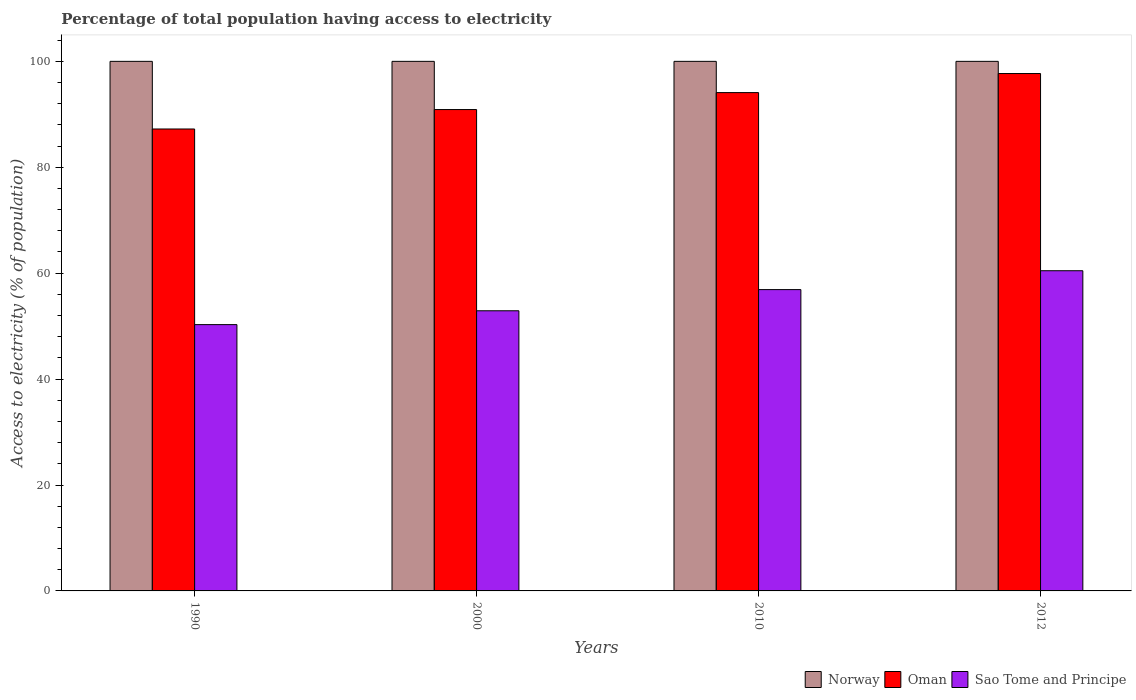How many groups of bars are there?
Offer a terse response. 4. Are the number of bars per tick equal to the number of legend labels?
Give a very brief answer. Yes. Are the number of bars on each tick of the X-axis equal?
Offer a very short reply. Yes. How many bars are there on the 1st tick from the left?
Offer a terse response. 3. What is the label of the 3rd group of bars from the left?
Give a very brief answer. 2010. In how many cases, is the number of bars for a given year not equal to the number of legend labels?
Provide a short and direct response. 0. What is the percentage of population that have access to electricity in Sao Tome and Principe in 2012?
Provide a short and direct response. 60.46. Across all years, what is the maximum percentage of population that have access to electricity in Oman?
Keep it short and to the point. 97.7. Across all years, what is the minimum percentage of population that have access to electricity in Sao Tome and Principe?
Provide a succinct answer. 50.29. In which year was the percentage of population that have access to electricity in Oman minimum?
Provide a succinct answer. 1990. What is the total percentage of population that have access to electricity in Sao Tome and Principe in the graph?
Ensure brevity in your answer.  220.55. What is the difference between the percentage of population that have access to electricity in Oman in 2010 and the percentage of population that have access to electricity in Norway in 2012?
Provide a short and direct response. -5.9. What is the average percentage of population that have access to electricity in Norway per year?
Give a very brief answer. 100. In the year 2012, what is the difference between the percentage of population that have access to electricity in Oman and percentage of population that have access to electricity in Norway?
Ensure brevity in your answer.  -2.3. In how many years, is the percentage of population that have access to electricity in Oman greater than 44 %?
Provide a short and direct response. 4. What is the ratio of the percentage of population that have access to electricity in Norway in 1990 to that in 2010?
Your response must be concise. 1. What is the difference between the highest and the second highest percentage of population that have access to electricity in Oman?
Give a very brief answer. 3.6. What is the difference between the highest and the lowest percentage of population that have access to electricity in Sao Tome and Principe?
Offer a terse response. 10.17. In how many years, is the percentage of population that have access to electricity in Norway greater than the average percentage of population that have access to electricity in Norway taken over all years?
Ensure brevity in your answer.  0. What does the 2nd bar from the left in 2000 represents?
Your answer should be compact. Oman. What does the 1st bar from the right in 2012 represents?
Your answer should be compact. Sao Tome and Principe. How many years are there in the graph?
Your answer should be very brief. 4. Does the graph contain any zero values?
Offer a very short reply. No. Does the graph contain grids?
Give a very brief answer. No. Where does the legend appear in the graph?
Your answer should be very brief. Bottom right. How many legend labels are there?
Ensure brevity in your answer.  3. What is the title of the graph?
Provide a succinct answer. Percentage of total population having access to electricity. What is the label or title of the X-axis?
Your answer should be very brief. Years. What is the label or title of the Y-axis?
Give a very brief answer. Access to electricity (% of population). What is the Access to electricity (% of population) in Norway in 1990?
Give a very brief answer. 100. What is the Access to electricity (% of population) of Oman in 1990?
Your response must be concise. 87.23. What is the Access to electricity (% of population) of Sao Tome and Principe in 1990?
Your answer should be compact. 50.29. What is the Access to electricity (% of population) of Oman in 2000?
Your answer should be very brief. 90.9. What is the Access to electricity (% of population) of Sao Tome and Principe in 2000?
Ensure brevity in your answer.  52.9. What is the Access to electricity (% of population) in Oman in 2010?
Make the answer very short. 94.1. What is the Access to electricity (% of population) in Sao Tome and Principe in 2010?
Provide a succinct answer. 56.9. What is the Access to electricity (% of population) of Oman in 2012?
Offer a terse response. 97.7. What is the Access to electricity (% of population) of Sao Tome and Principe in 2012?
Give a very brief answer. 60.46. Across all years, what is the maximum Access to electricity (% of population) of Norway?
Provide a succinct answer. 100. Across all years, what is the maximum Access to electricity (% of population) in Oman?
Provide a succinct answer. 97.7. Across all years, what is the maximum Access to electricity (% of population) in Sao Tome and Principe?
Provide a succinct answer. 60.46. Across all years, what is the minimum Access to electricity (% of population) of Norway?
Your answer should be compact. 100. Across all years, what is the minimum Access to electricity (% of population) of Oman?
Provide a succinct answer. 87.23. Across all years, what is the minimum Access to electricity (% of population) of Sao Tome and Principe?
Keep it short and to the point. 50.29. What is the total Access to electricity (% of population) in Oman in the graph?
Offer a very short reply. 369.92. What is the total Access to electricity (% of population) in Sao Tome and Principe in the graph?
Make the answer very short. 220.55. What is the difference between the Access to electricity (% of population) in Norway in 1990 and that in 2000?
Offer a very short reply. 0. What is the difference between the Access to electricity (% of population) of Oman in 1990 and that in 2000?
Give a very brief answer. -3.67. What is the difference between the Access to electricity (% of population) of Sao Tome and Principe in 1990 and that in 2000?
Provide a succinct answer. -2.61. What is the difference between the Access to electricity (% of population) in Norway in 1990 and that in 2010?
Your answer should be very brief. 0. What is the difference between the Access to electricity (% of population) in Oman in 1990 and that in 2010?
Offer a very short reply. -6.87. What is the difference between the Access to electricity (% of population) of Sao Tome and Principe in 1990 and that in 2010?
Ensure brevity in your answer.  -6.61. What is the difference between the Access to electricity (% of population) in Oman in 1990 and that in 2012?
Your answer should be compact. -10.47. What is the difference between the Access to electricity (% of population) in Sao Tome and Principe in 1990 and that in 2012?
Your response must be concise. -10.17. What is the difference between the Access to electricity (% of population) of Oman in 2000 and that in 2010?
Your response must be concise. -3.2. What is the difference between the Access to electricity (% of population) in Oman in 2000 and that in 2012?
Offer a terse response. -6.8. What is the difference between the Access to electricity (% of population) in Sao Tome and Principe in 2000 and that in 2012?
Offer a terse response. -7.56. What is the difference between the Access to electricity (% of population) in Oman in 2010 and that in 2012?
Your answer should be very brief. -3.6. What is the difference between the Access to electricity (% of population) in Sao Tome and Principe in 2010 and that in 2012?
Your answer should be compact. -3.56. What is the difference between the Access to electricity (% of population) in Norway in 1990 and the Access to electricity (% of population) in Oman in 2000?
Offer a terse response. 9.1. What is the difference between the Access to electricity (% of population) in Norway in 1990 and the Access to electricity (% of population) in Sao Tome and Principe in 2000?
Your answer should be compact. 47.1. What is the difference between the Access to electricity (% of population) in Oman in 1990 and the Access to electricity (% of population) in Sao Tome and Principe in 2000?
Ensure brevity in your answer.  34.33. What is the difference between the Access to electricity (% of population) in Norway in 1990 and the Access to electricity (% of population) in Sao Tome and Principe in 2010?
Your answer should be compact. 43.1. What is the difference between the Access to electricity (% of population) in Oman in 1990 and the Access to electricity (% of population) in Sao Tome and Principe in 2010?
Offer a terse response. 30.33. What is the difference between the Access to electricity (% of population) in Norway in 1990 and the Access to electricity (% of population) in Oman in 2012?
Provide a short and direct response. 2.3. What is the difference between the Access to electricity (% of population) of Norway in 1990 and the Access to electricity (% of population) of Sao Tome and Principe in 2012?
Provide a succinct answer. 39.54. What is the difference between the Access to electricity (% of population) of Oman in 1990 and the Access to electricity (% of population) of Sao Tome and Principe in 2012?
Offer a very short reply. 26.77. What is the difference between the Access to electricity (% of population) of Norway in 2000 and the Access to electricity (% of population) of Sao Tome and Principe in 2010?
Offer a terse response. 43.1. What is the difference between the Access to electricity (% of population) in Oman in 2000 and the Access to electricity (% of population) in Sao Tome and Principe in 2010?
Offer a terse response. 34. What is the difference between the Access to electricity (% of population) in Norway in 2000 and the Access to electricity (% of population) in Oman in 2012?
Your answer should be very brief. 2.3. What is the difference between the Access to electricity (% of population) in Norway in 2000 and the Access to electricity (% of population) in Sao Tome and Principe in 2012?
Your answer should be very brief. 39.54. What is the difference between the Access to electricity (% of population) in Oman in 2000 and the Access to electricity (% of population) in Sao Tome and Principe in 2012?
Make the answer very short. 30.44. What is the difference between the Access to electricity (% of population) in Norway in 2010 and the Access to electricity (% of population) in Oman in 2012?
Make the answer very short. 2.3. What is the difference between the Access to electricity (% of population) in Norway in 2010 and the Access to electricity (% of population) in Sao Tome and Principe in 2012?
Offer a very short reply. 39.54. What is the difference between the Access to electricity (% of population) in Oman in 2010 and the Access to electricity (% of population) in Sao Tome and Principe in 2012?
Your answer should be compact. 33.64. What is the average Access to electricity (% of population) of Norway per year?
Give a very brief answer. 100. What is the average Access to electricity (% of population) in Oman per year?
Your response must be concise. 92.48. What is the average Access to electricity (% of population) in Sao Tome and Principe per year?
Offer a terse response. 55.14. In the year 1990, what is the difference between the Access to electricity (% of population) in Norway and Access to electricity (% of population) in Oman?
Offer a very short reply. 12.77. In the year 1990, what is the difference between the Access to electricity (% of population) of Norway and Access to electricity (% of population) of Sao Tome and Principe?
Keep it short and to the point. 49.71. In the year 1990, what is the difference between the Access to electricity (% of population) in Oman and Access to electricity (% of population) in Sao Tome and Principe?
Make the answer very short. 36.94. In the year 2000, what is the difference between the Access to electricity (% of population) of Norway and Access to electricity (% of population) of Oman?
Provide a short and direct response. 9.1. In the year 2000, what is the difference between the Access to electricity (% of population) of Norway and Access to electricity (% of population) of Sao Tome and Principe?
Provide a succinct answer. 47.1. In the year 2000, what is the difference between the Access to electricity (% of population) of Oman and Access to electricity (% of population) of Sao Tome and Principe?
Give a very brief answer. 38. In the year 2010, what is the difference between the Access to electricity (% of population) in Norway and Access to electricity (% of population) in Oman?
Make the answer very short. 5.9. In the year 2010, what is the difference between the Access to electricity (% of population) of Norway and Access to electricity (% of population) of Sao Tome and Principe?
Keep it short and to the point. 43.1. In the year 2010, what is the difference between the Access to electricity (% of population) in Oman and Access to electricity (% of population) in Sao Tome and Principe?
Your answer should be compact. 37.2. In the year 2012, what is the difference between the Access to electricity (% of population) in Norway and Access to electricity (% of population) in Oman?
Ensure brevity in your answer.  2.3. In the year 2012, what is the difference between the Access to electricity (% of population) of Norway and Access to electricity (% of population) of Sao Tome and Principe?
Your answer should be compact. 39.54. In the year 2012, what is the difference between the Access to electricity (% of population) of Oman and Access to electricity (% of population) of Sao Tome and Principe?
Your answer should be very brief. 37.24. What is the ratio of the Access to electricity (% of population) of Norway in 1990 to that in 2000?
Give a very brief answer. 1. What is the ratio of the Access to electricity (% of population) of Oman in 1990 to that in 2000?
Make the answer very short. 0.96. What is the ratio of the Access to electricity (% of population) in Sao Tome and Principe in 1990 to that in 2000?
Keep it short and to the point. 0.95. What is the ratio of the Access to electricity (% of population) of Norway in 1990 to that in 2010?
Your response must be concise. 1. What is the ratio of the Access to electricity (% of population) in Oman in 1990 to that in 2010?
Offer a very short reply. 0.93. What is the ratio of the Access to electricity (% of population) of Sao Tome and Principe in 1990 to that in 2010?
Keep it short and to the point. 0.88. What is the ratio of the Access to electricity (% of population) of Oman in 1990 to that in 2012?
Provide a succinct answer. 0.89. What is the ratio of the Access to electricity (% of population) in Sao Tome and Principe in 1990 to that in 2012?
Ensure brevity in your answer.  0.83. What is the ratio of the Access to electricity (% of population) in Sao Tome and Principe in 2000 to that in 2010?
Make the answer very short. 0.93. What is the ratio of the Access to electricity (% of population) of Norway in 2000 to that in 2012?
Your answer should be compact. 1. What is the ratio of the Access to electricity (% of population) in Oman in 2000 to that in 2012?
Keep it short and to the point. 0.93. What is the ratio of the Access to electricity (% of population) in Sao Tome and Principe in 2000 to that in 2012?
Your answer should be compact. 0.87. What is the ratio of the Access to electricity (% of population) of Norway in 2010 to that in 2012?
Provide a short and direct response. 1. What is the ratio of the Access to electricity (% of population) in Oman in 2010 to that in 2012?
Provide a succinct answer. 0.96. What is the ratio of the Access to electricity (% of population) in Sao Tome and Principe in 2010 to that in 2012?
Provide a succinct answer. 0.94. What is the difference between the highest and the second highest Access to electricity (% of population) in Norway?
Offer a very short reply. 0. What is the difference between the highest and the second highest Access to electricity (% of population) of Oman?
Provide a succinct answer. 3.6. What is the difference between the highest and the second highest Access to electricity (% of population) in Sao Tome and Principe?
Provide a succinct answer. 3.56. What is the difference between the highest and the lowest Access to electricity (% of population) in Oman?
Offer a very short reply. 10.47. What is the difference between the highest and the lowest Access to electricity (% of population) in Sao Tome and Principe?
Ensure brevity in your answer.  10.17. 